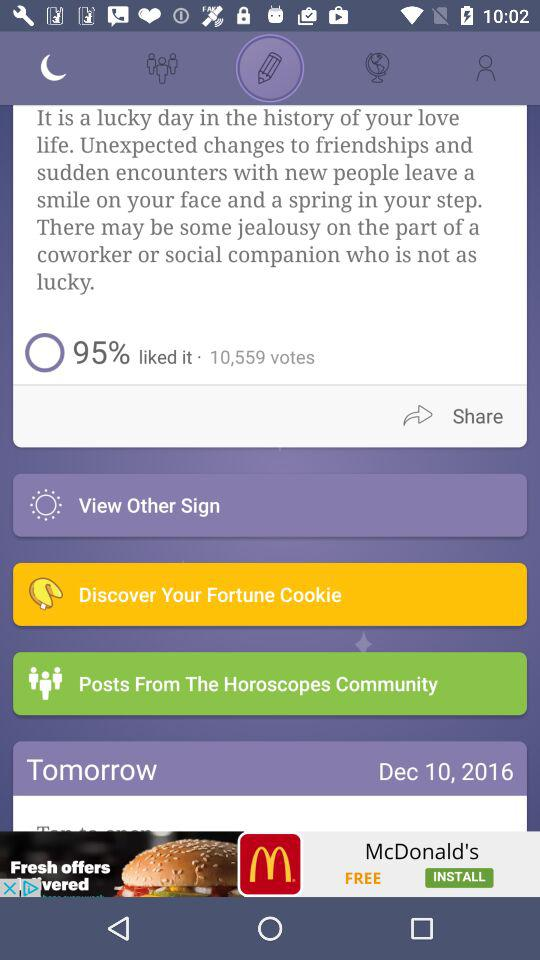How many votes are shown? The number of votes are 10,559. 